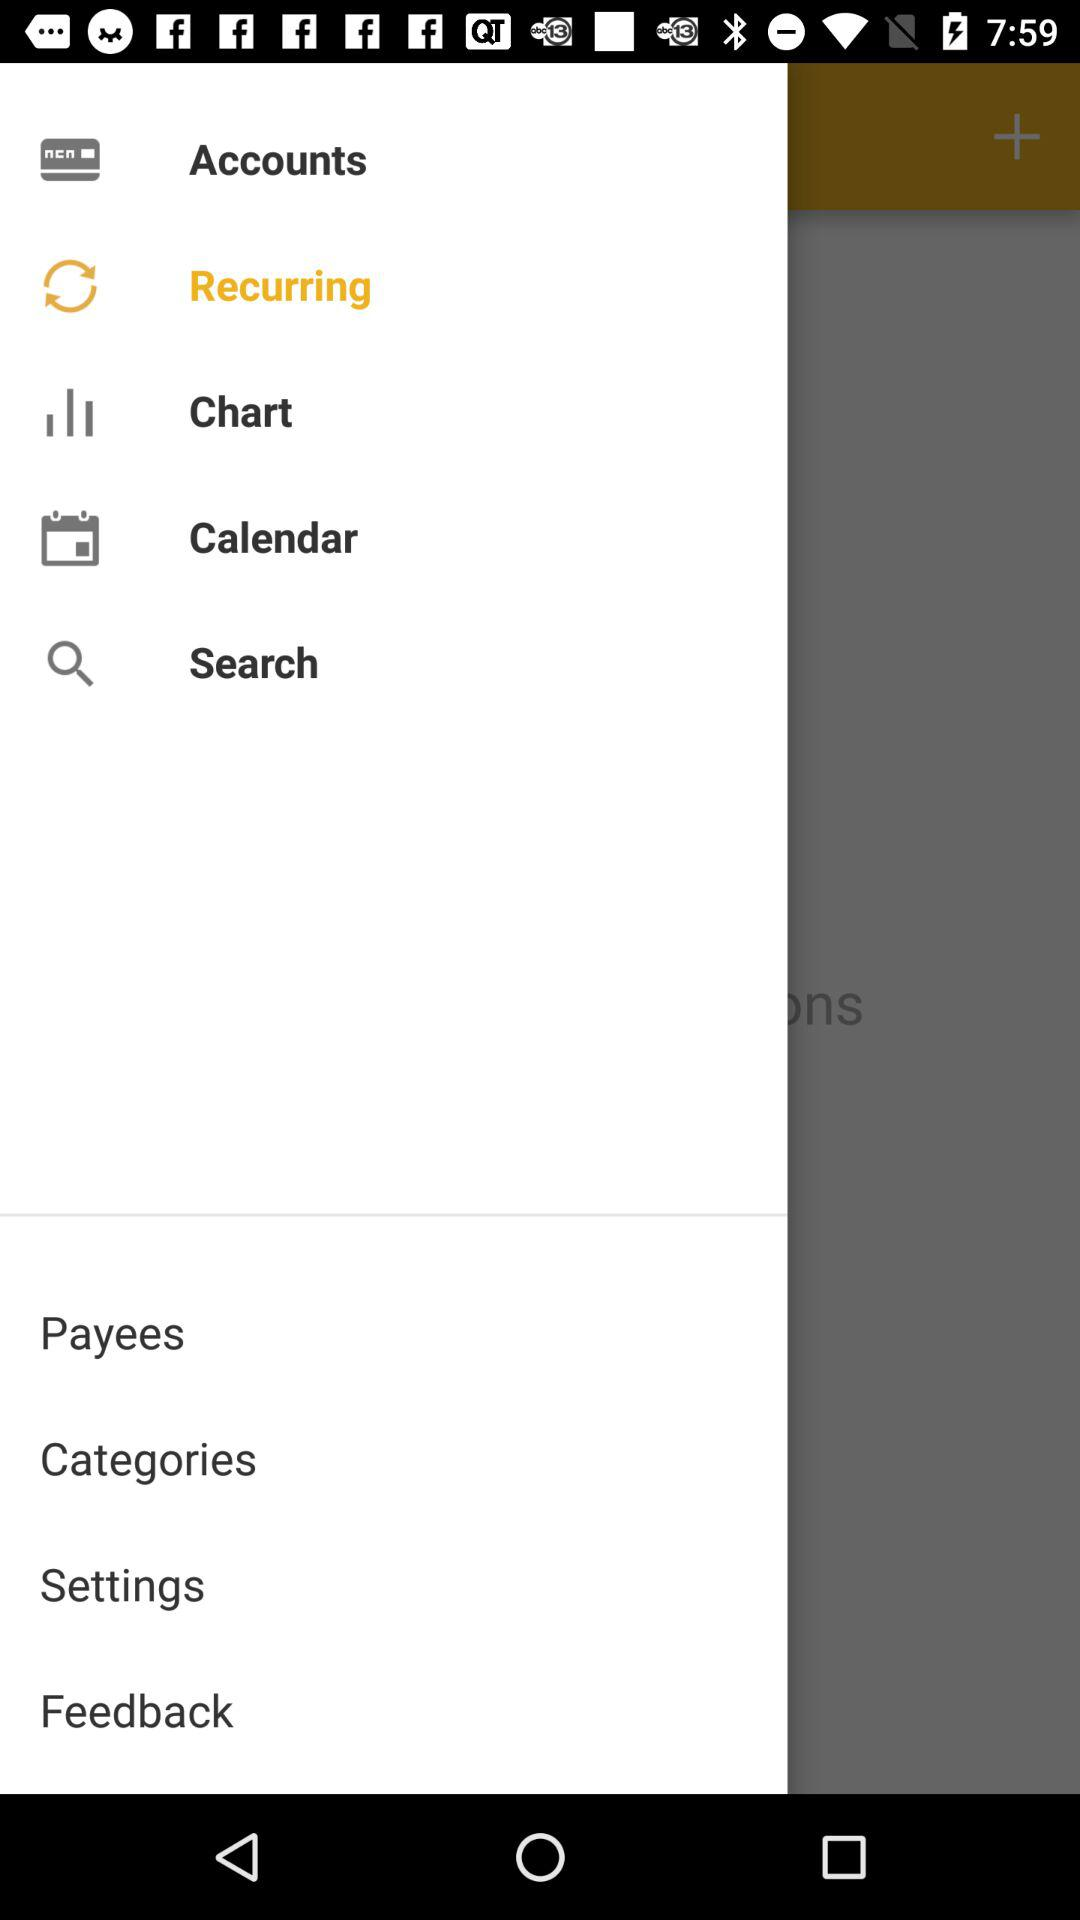What is the selected option? The selected option is recurring. 